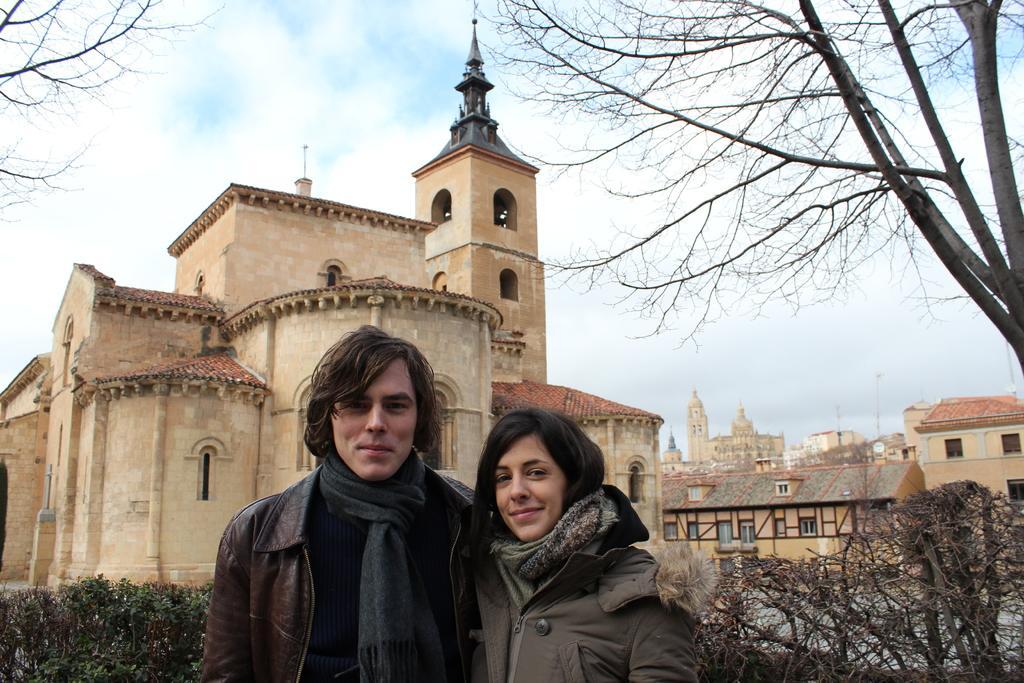In one or two sentences, can you explain what this image depicts? In this image I can see 2 people standing, they are wearing coats. There are plants and buildings at the back. There is a tree on the right and there is sky at the top. 